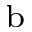Convert formula to latex. <formula><loc_0><loc_0><loc_500><loc_500>^ { b }</formula> 